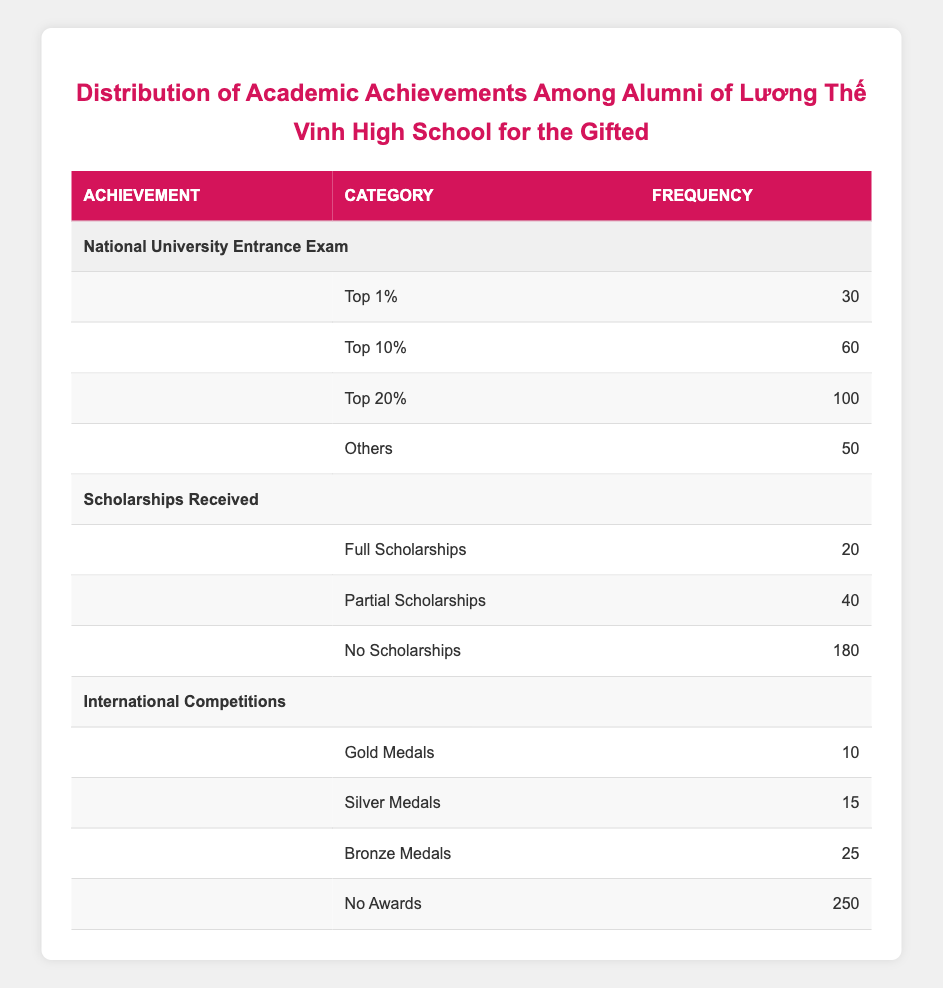What is the frequency of alumni who achieved Gold Medals in International Competitions? The table lists the frequency of each achievement, and for the category of Gold Medals under International Competitions, it shows a frequency of 10.
Answer: 10 What percentage of alumni received Full Scholarships compared to those who received No Scholarships? The frequency of Full Scholarships is 20 and No Scholarships is 180. To find the percentage, divide the frequency of Full Scholarships by the frequency of No Scholarships and multiply by 100: (20/180) * 100 = 11.11%.
Answer: 11.11% Is it true that more alumni achieved Top 20% in the National University Entrance Exam than received Silver Medals in International Competitions? The frequency of those in the Top 20% of the National University Entrance Exam is 100, while Silver Medals in International Competitions has a frequency of 15. Since 100 is greater than 15, the statement is true.
Answer: Yes What is the total frequency of alumni who did not receive any scholarships? The table shows that the frequency for No Scholarships is 180. This is the total number of alumni who did not receive any form of scholarship.
Answer: 180 How many more alumni achieved Top 10% compared to those who received Partial Scholarships? The frequency for Top 10% is 60 and for Partial Scholarships, it is 40. To find the difference, subtract the frequency of Partial Scholarships from the frequency of Top 10%: 60 - 40 = 20.
Answer: 20 What is the combined frequency of all alumni who received medals in International Competitions? The frequencies are Gold Medals (10), Silver Medals (15), and Bronze Medals (25). To find the combined frequency, sum these values: 10 + 15 + 25 = 50.
Answer: 50 How many alumni fall into the category of Others in the National University Entrance Exam? The frequency for the category "Others" in the National University Entrance Exam is given as 50 in the table.
Answer: 50 Which category has the highest frequency of achievements? When comparing frequencies across all categories, the highest frequency is found under "No Awards" in International Competitions, with a frequency of 250.
Answer: No Awards in International Competitions What is the average frequency of academic achievements in the National University Entrance Exam? The frequencies for National University Entrance Exam categories are 30, 60, 100, and 50. To find the average, sum these values (30 + 60 + 100 + 50 = 240) and divide by the number of categories (4): 240/4 = 60.
Answer: 60 